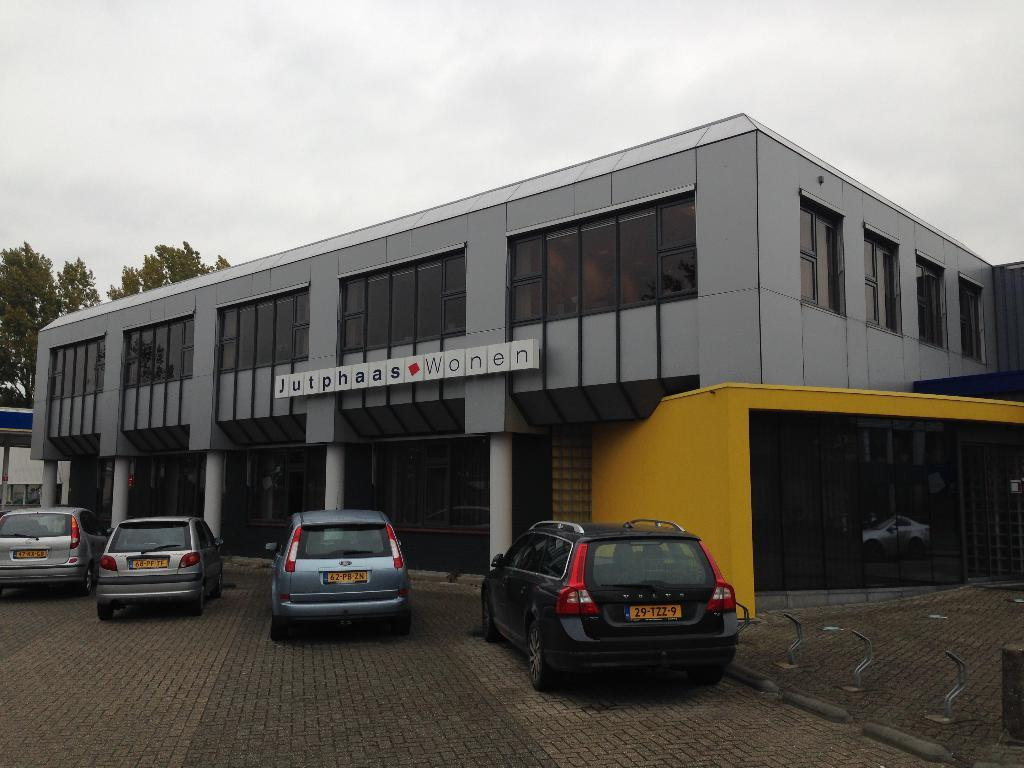How many cars can be seen in the image? There are four cars in the image. What can be seen on the cars in the image? The number plates of the cars are visible. What type of path is present in the image? There is a footpath in the image. What type of structure is visible in the image? There is a building in the image. What is visible in the image that might be used for communication? There is text visible in the image. What type of vegetation is present in the image? Trees are present in the image. What is the condition of the sky in the image? The sky is cloudy in the image. What type of silk fabric is draped over the arch in the image? There is no arch or silk fabric present in the image. 